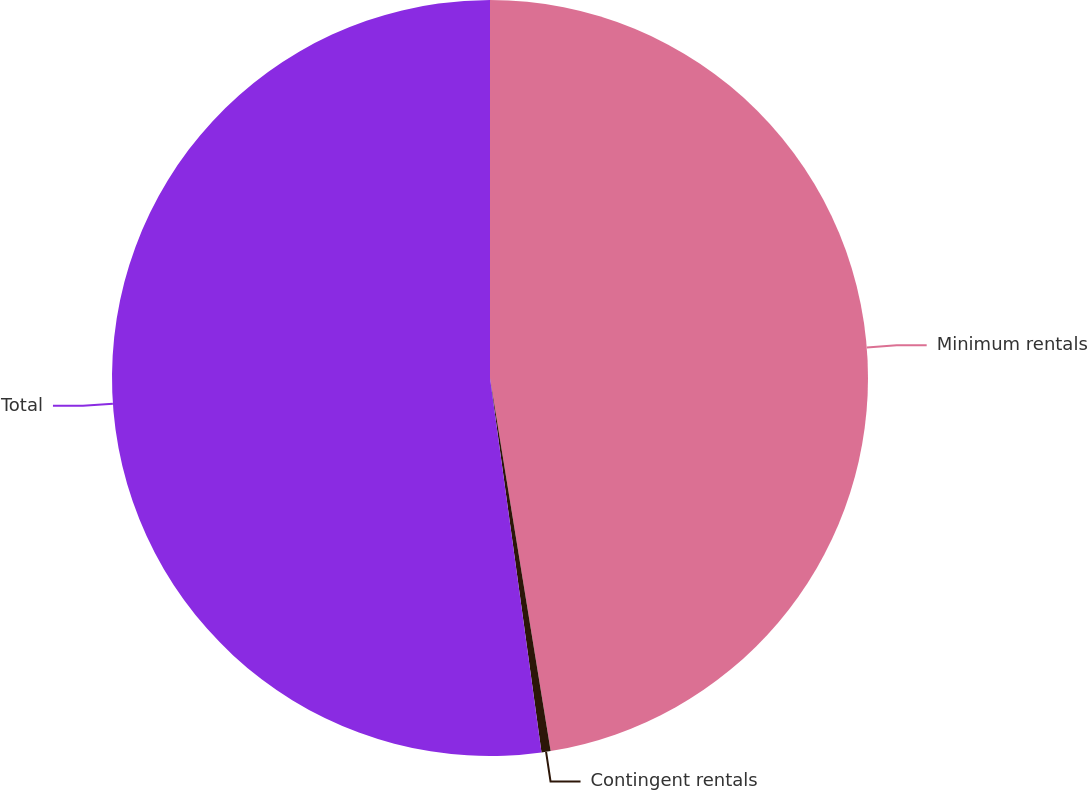Convert chart. <chart><loc_0><loc_0><loc_500><loc_500><pie_chart><fcel>Minimum rentals<fcel>Contingent rentals<fcel>Total<nl><fcel>47.43%<fcel>0.39%<fcel>52.17%<nl></chart> 